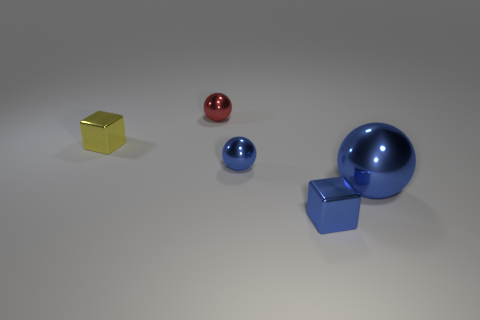Subtract all blue balls. How many balls are left? 1 Subtract all red balls. How many balls are left? 2 Add 2 red spheres. How many objects exist? 7 Subtract 0 gray blocks. How many objects are left? 5 Subtract all blocks. How many objects are left? 3 Subtract 3 balls. How many balls are left? 0 Subtract all red balls. Subtract all green blocks. How many balls are left? 2 Subtract all purple spheres. How many blue blocks are left? 1 Subtract all purple balls. Subtract all tiny yellow things. How many objects are left? 4 Add 5 small metallic objects. How many small metallic objects are left? 9 